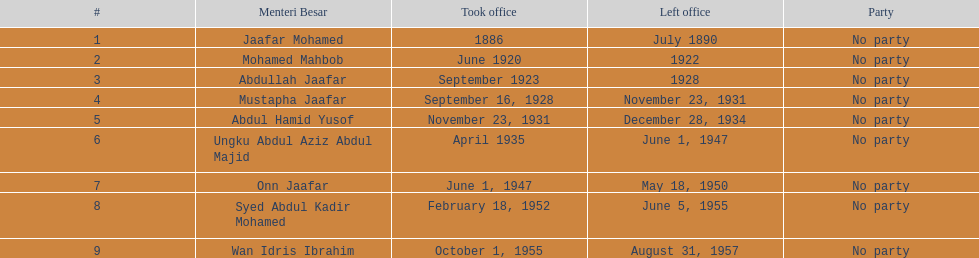Who served in the office immediately preceding abdullah jaafar? Mohamed Mahbob. 